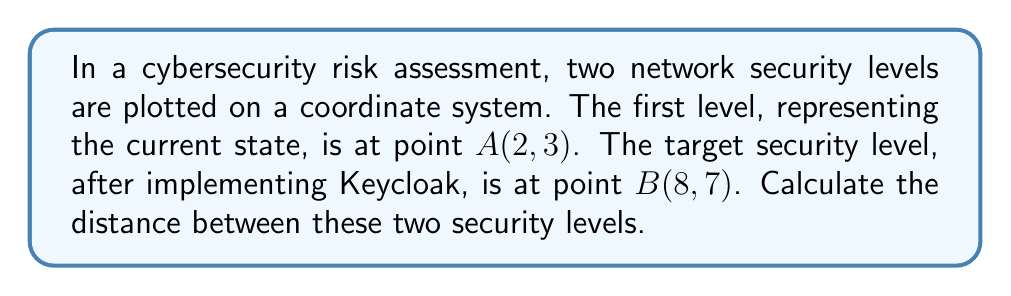Could you help me with this problem? To calculate the distance between two points in a coordinate system, we use the distance formula, which is derived from the Pythagorean theorem:

$$d = \sqrt{(x_2 - x_1)^2 + (y_2 - y_1)^2}$$

Where:
$(x_1, y_1)$ represents the coordinates of the first point (A)
$(x_2, y_2)$ represents the coordinates of the second point (B)

Given:
Point A (current security level): $(2, 3)$
Point B (target security level with Keycloak): $(8, 7)$

Step 1: Identify the coordinates
$x_1 = 2$, $y_1 = 3$
$x_2 = 8$, $y_2 = 7$

Step 2: Substitute the values into the distance formula
$$d = \sqrt{(8 - 2)^2 + (7 - 3)^2}$$

Step 3: Simplify the expressions inside the parentheses
$$d = \sqrt{6^2 + 4^2}$$

Step 4: Calculate the squares
$$d = \sqrt{36 + 16}$$

Step 5: Add the values under the square root
$$d = \sqrt{52}$$

Step 6: Simplify the square root
$$d = 2\sqrt{13}$$

Therefore, the distance between the current security level and the target security level after implementing Keycloak is $2\sqrt{13}$ units.
Answer: $2\sqrt{13}$ units 